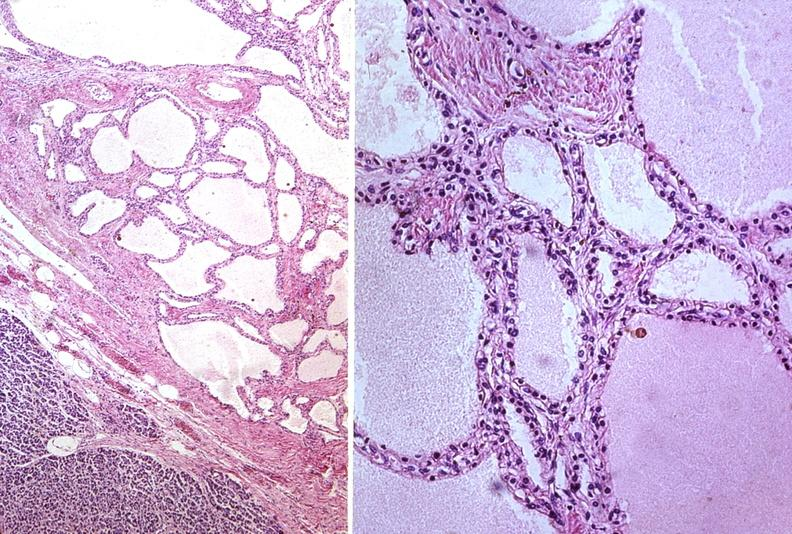s pancreas present?
Answer the question using a single word or phrase. Yes 